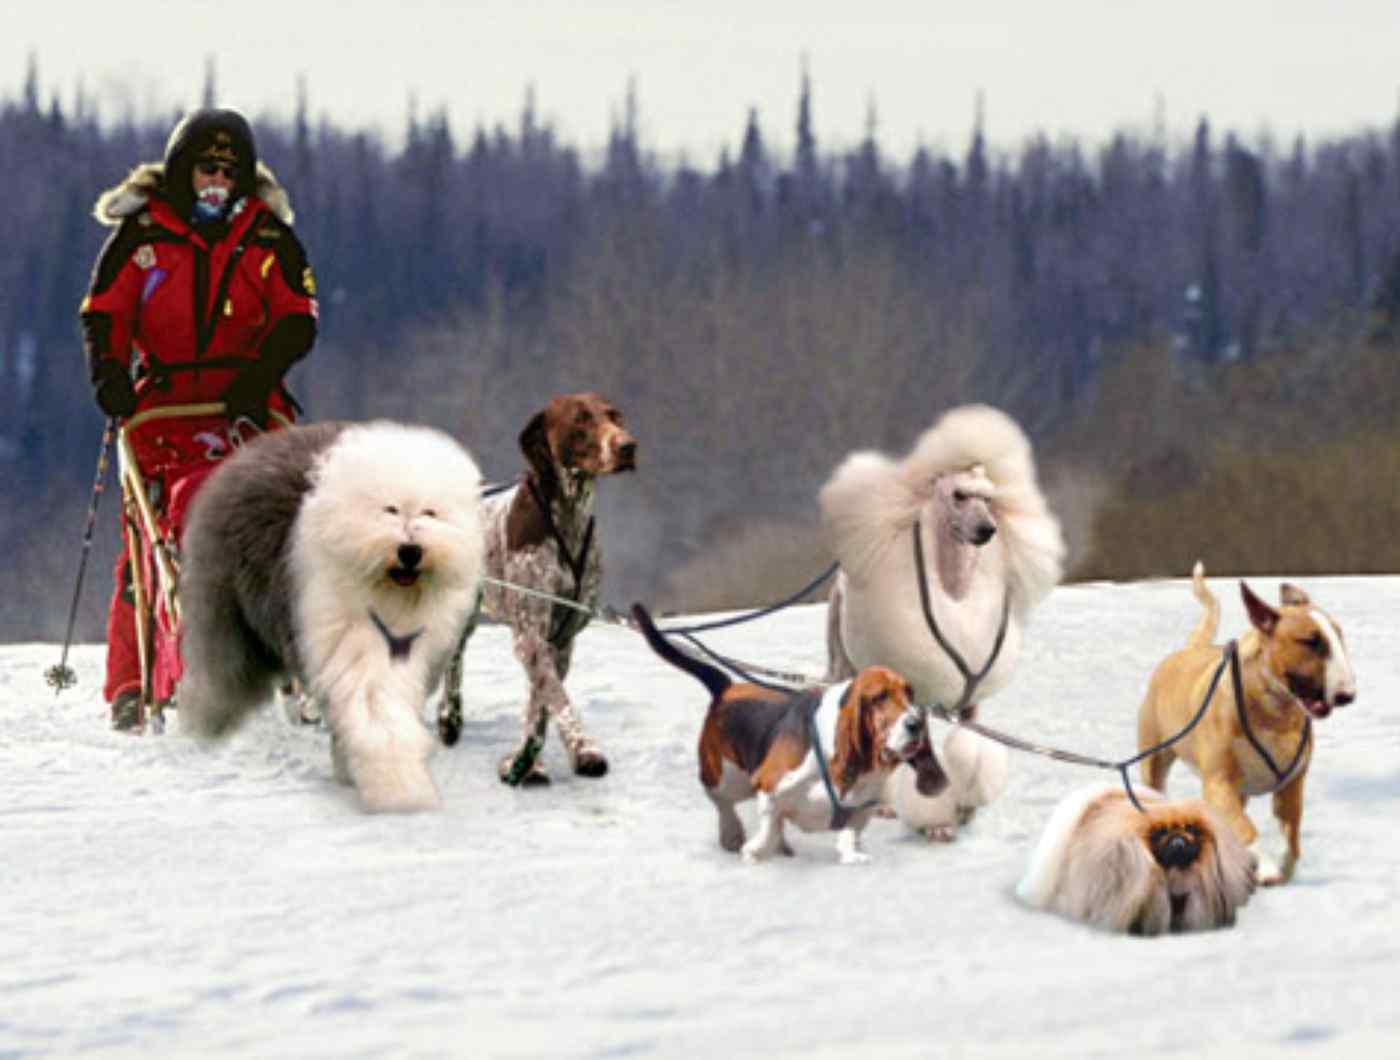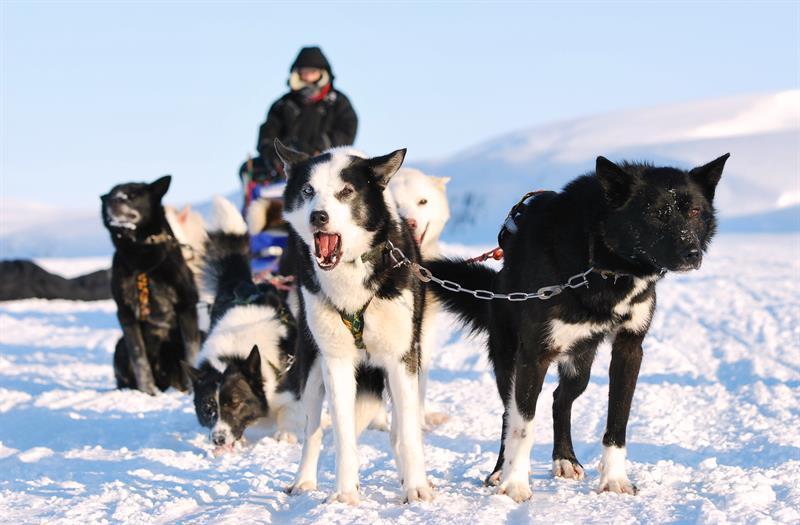The first image is the image on the left, the second image is the image on the right. For the images shown, is this caption "None of the harnessed dogs in one image are typical husky-type sled dogs." true? Answer yes or no. Yes. The first image is the image on the left, the second image is the image on the right. Analyze the images presented: Is the assertion "In one image, a team of dogs is pulling a sled on which a person is standing, while a second image shows a team of dogs up close, standing in their harnesses." valid? Answer yes or no. No. 